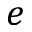Convert formula to latex. <formula><loc_0><loc_0><loc_500><loc_500>e</formula> 